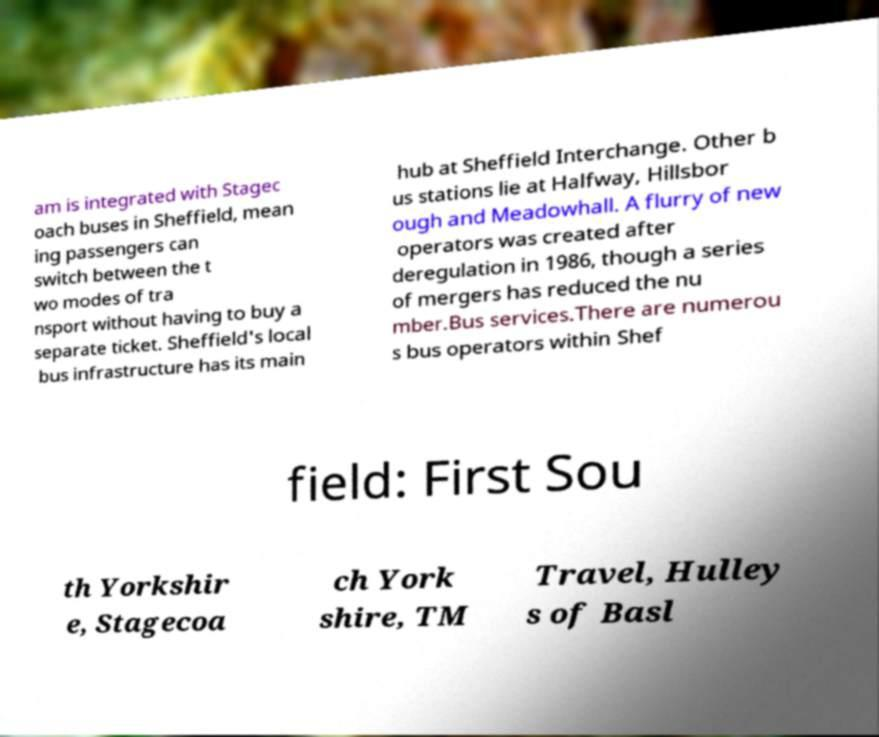Could you extract and type out the text from this image? am is integrated with Stagec oach buses in Sheffield, mean ing passengers can switch between the t wo modes of tra nsport without having to buy a separate ticket. Sheffield's local bus infrastructure has its main hub at Sheffield Interchange. Other b us stations lie at Halfway, Hillsbor ough and Meadowhall. A flurry of new operators was created after deregulation in 1986, though a series of mergers has reduced the nu mber.Bus services.There are numerou s bus operators within Shef field: First Sou th Yorkshir e, Stagecoa ch York shire, TM Travel, Hulley s of Basl 